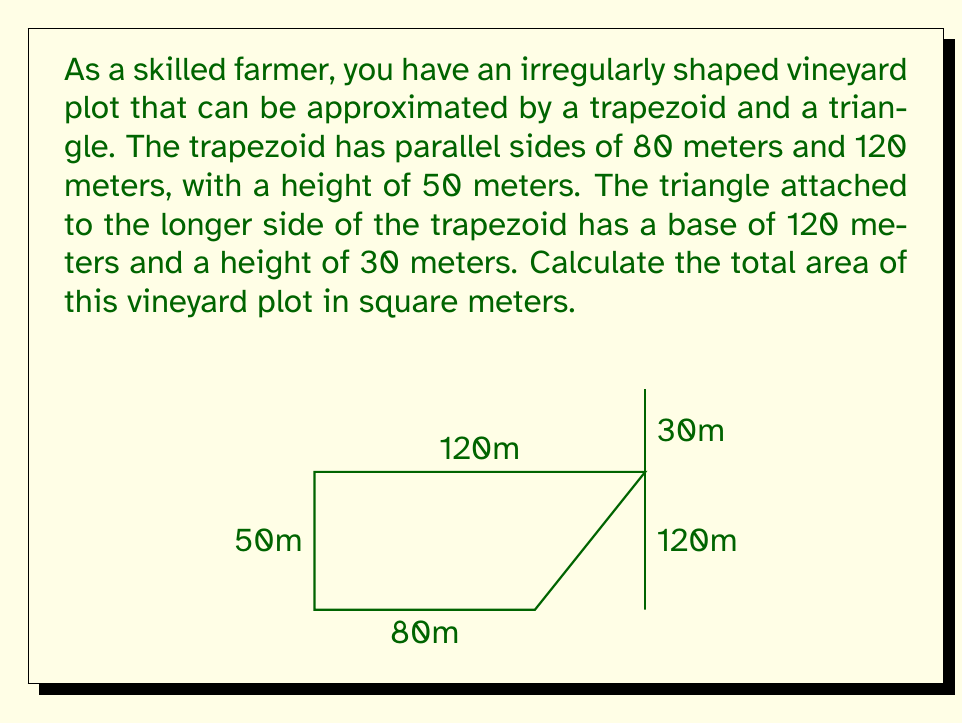Show me your answer to this math problem. To solve this problem, we need to calculate the areas of the trapezoid and triangle separately, then add them together.

1. Area of the trapezoid:
   The formula for the area of a trapezoid is:
   $$A_{trapezoid} = \frac{1}{2}(a+b)h$$
   where $a$ and $b$ are the parallel sides and $h$ is the height.

   Plugging in our values:
   $$A_{trapezoid} = \frac{1}{2}(80+120) \times 50 = 100 \times 50 = 5000 \text{ m}^2$$

2. Area of the triangle:
   The formula for the area of a triangle is:
   $$A_{triangle} = \frac{1}{2}bh$$
   where $b$ is the base and $h$ is the height.

   Plugging in our values:
   $$A_{triangle} = \frac{1}{2} \times 120 \times 30 = 1800 \text{ m}^2$$

3. Total area:
   To get the total area, we add the areas of the trapezoid and triangle:
   $$A_{total} = A_{trapezoid} + A_{triangle} = 5000 + 1800 = 6800 \text{ m}^2$$

Therefore, the total area of the vineyard plot is 6800 square meters.
Answer: 6800 m² 